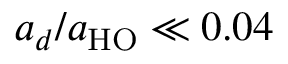Convert formula to latex. <formula><loc_0><loc_0><loc_500><loc_500>a _ { d } / a _ { H O } \ll 0 . 0 4</formula> 